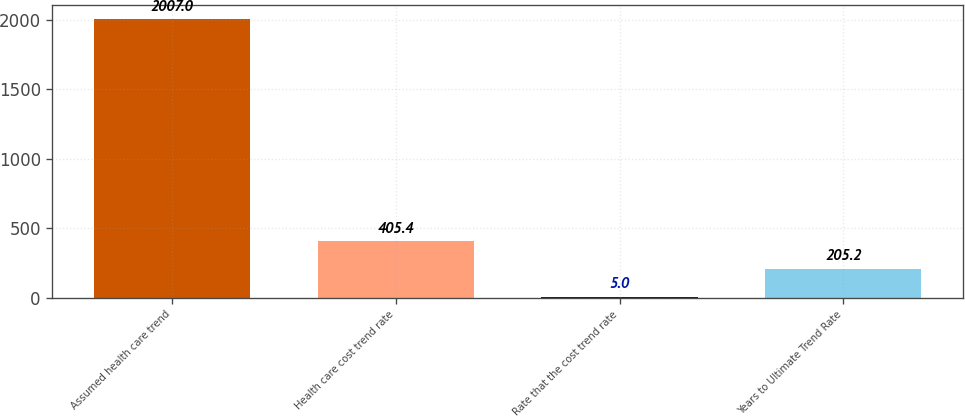Convert chart to OTSL. <chart><loc_0><loc_0><loc_500><loc_500><bar_chart><fcel>Assumed health care trend<fcel>Health care cost trend rate<fcel>Rate that the cost trend rate<fcel>Years to Ultimate Trend Rate<nl><fcel>2007<fcel>405.4<fcel>5<fcel>205.2<nl></chart> 